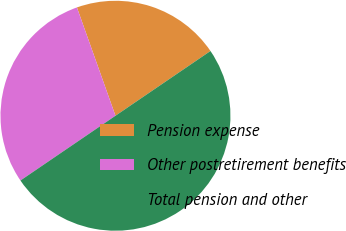<chart> <loc_0><loc_0><loc_500><loc_500><pie_chart><fcel>Pension expense<fcel>Other postretirement benefits<fcel>Total pension and other<nl><fcel>20.92%<fcel>29.08%<fcel>50.0%<nl></chart> 